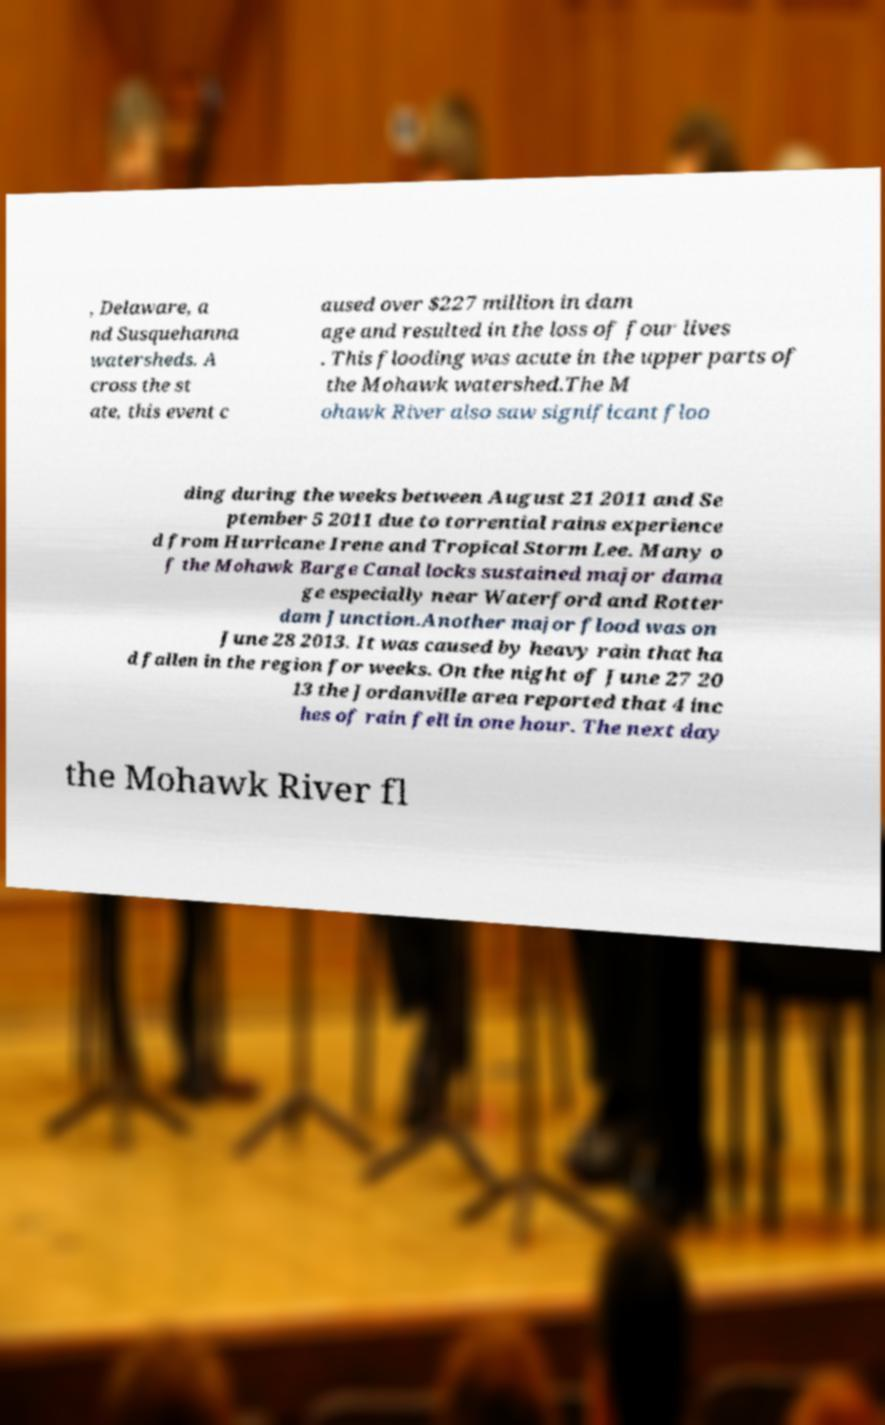What messages or text are displayed in this image? I need them in a readable, typed format. , Delaware, a nd Susquehanna watersheds. A cross the st ate, this event c aused over $227 million in dam age and resulted in the loss of four lives . This flooding was acute in the upper parts of the Mohawk watershed.The M ohawk River also saw significant floo ding during the weeks between August 21 2011 and Se ptember 5 2011 due to torrential rains experience d from Hurricane Irene and Tropical Storm Lee. Many o f the Mohawk Barge Canal locks sustained major dama ge especially near Waterford and Rotter dam Junction.Another major flood was on June 28 2013. It was caused by heavy rain that ha d fallen in the region for weeks. On the night of June 27 20 13 the Jordanville area reported that 4 inc hes of rain fell in one hour. The next day the Mohawk River fl 